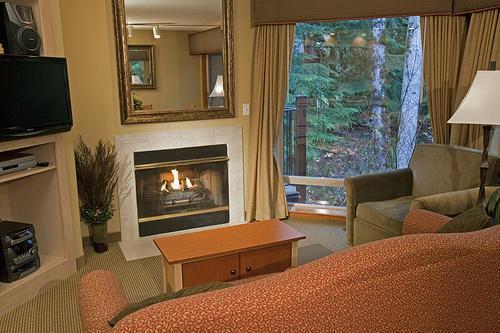How many couches are visible?
Give a very brief answer. 1. 